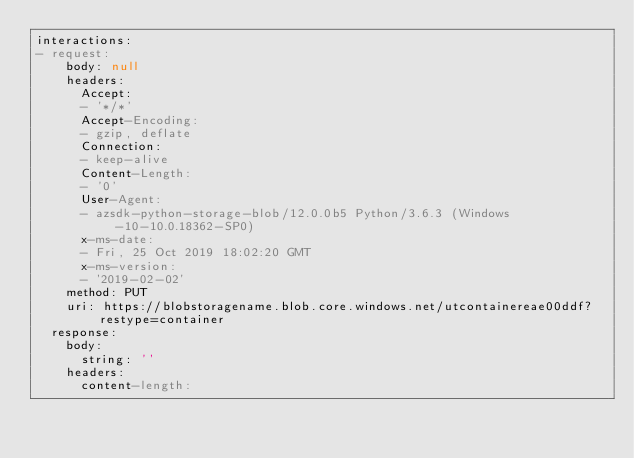Convert code to text. <code><loc_0><loc_0><loc_500><loc_500><_YAML_>interactions:
- request:
    body: null
    headers:
      Accept:
      - '*/*'
      Accept-Encoding:
      - gzip, deflate
      Connection:
      - keep-alive
      Content-Length:
      - '0'
      User-Agent:
      - azsdk-python-storage-blob/12.0.0b5 Python/3.6.3 (Windows-10-10.0.18362-SP0)
      x-ms-date:
      - Fri, 25 Oct 2019 18:02:20 GMT
      x-ms-version:
      - '2019-02-02'
    method: PUT
    uri: https://blobstoragename.blob.core.windows.net/utcontainereae00ddf?restype=container
  response:
    body:
      string: ''
    headers:
      content-length:</code> 